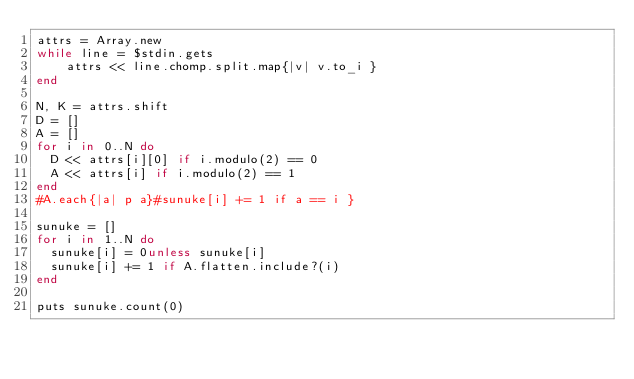<code> <loc_0><loc_0><loc_500><loc_500><_Ruby_>attrs = Array.new
while line = $stdin.gets
    attrs << line.chomp.split.map{|v| v.to_i }
end

N, K = attrs.shift
D = []
A = []
for i in 0..N do
  D << attrs[i][0] if i.modulo(2) == 0
  A << attrs[i] if i.modulo(2) == 1
end
#A.each{|a| p a}#sunuke[i] += 1 if a == i }

sunuke = []
for i in 1..N do
  sunuke[i] = 0unless sunuke[i]
  sunuke[i] += 1 if A.flatten.include?(i)
end

puts sunuke.count(0)</code> 